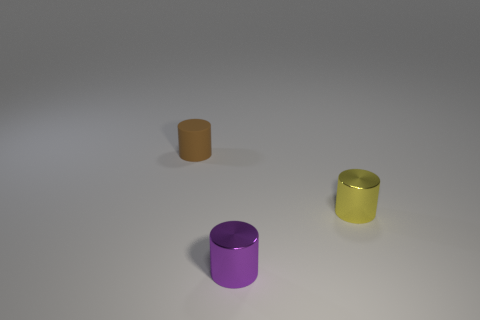Subtract all small brown matte cylinders. How many cylinders are left? 2 Subtract 3 cylinders. How many cylinders are left? 0 Subtract all brown cylinders. How many cylinders are left? 2 Add 1 small red rubber objects. How many objects exist? 4 Subtract all purple objects. Subtract all tiny gray metallic cylinders. How many objects are left? 2 Add 1 matte things. How many matte things are left? 2 Add 1 tiny matte cylinders. How many tiny matte cylinders exist? 2 Subtract 0 cyan blocks. How many objects are left? 3 Subtract all green cylinders. Subtract all blue balls. How many cylinders are left? 3 Subtract all yellow cubes. How many purple cylinders are left? 1 